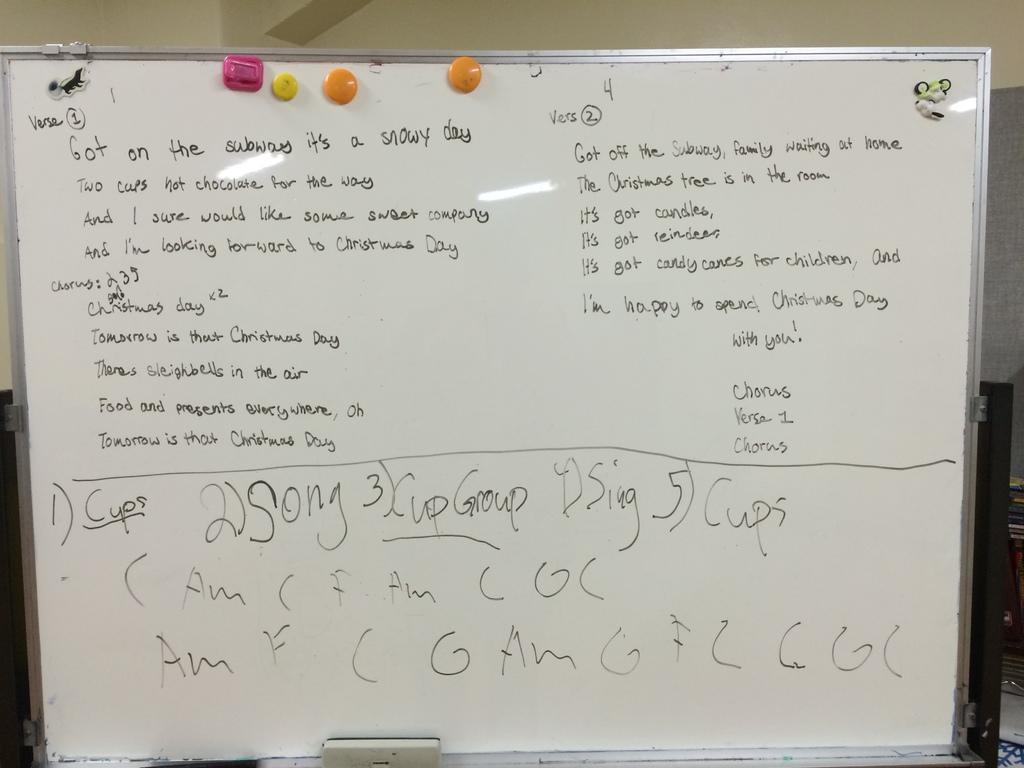<image>
Summarize the visual content of the image. A whiteboard that says "Got on the subway it's a snowy day" on it. 